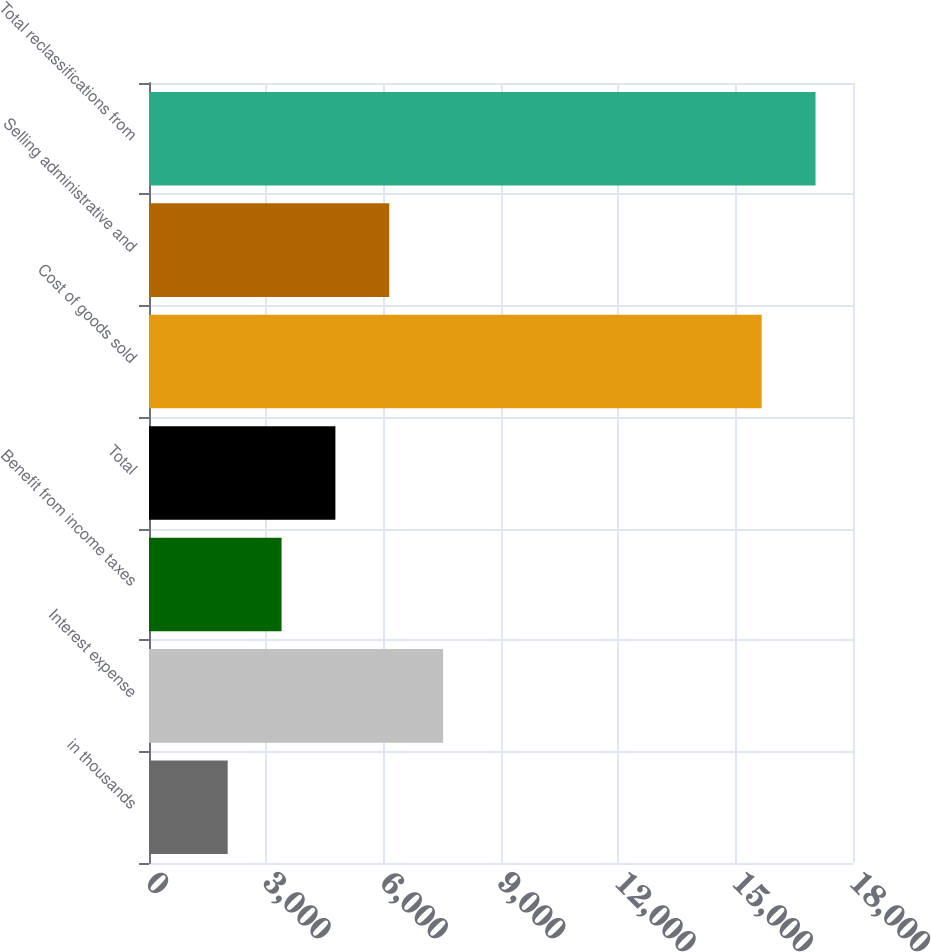Convert chart. <chart><loc_0><loc_0><loc_500><loc_500><bar_chart><fcel>in thousands<fcel>Interest expense<fcel>Benefit from income taxes<fcel>Total<fcel>Cost of goods sold<fcel>Selling administrative and<fcel>Total reclassifications from<nl><fcel>2012<fcel>7519.6<fcel>3388.9<fcel>4765.8<fcel>15665<fcel>6142.7<fcel>17041.9<nl></chart> 